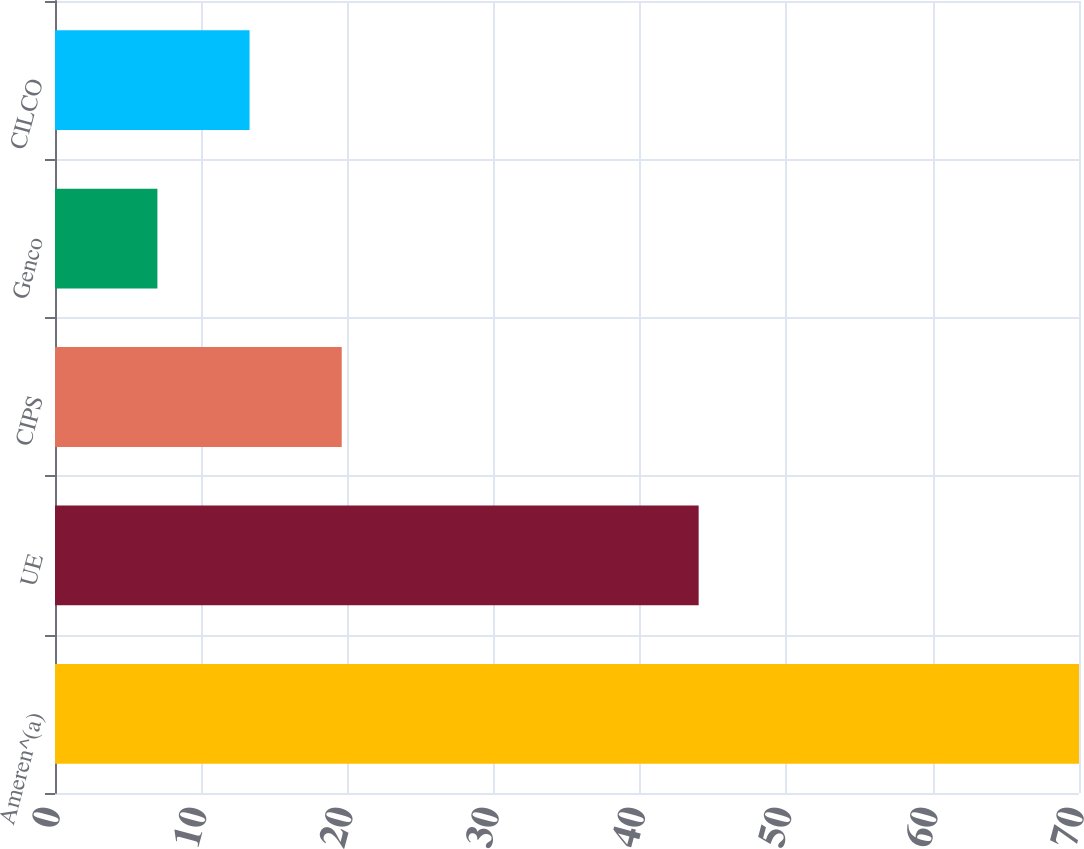Convert chart to OTSL. <chart><loc_0><loc_0><loc_500><loc_500><bar_chart><fcel>Ameren^(a)<fcel>UE<fcel>CIPS<fcel>Genco<fcel>CILCO<nl><fcel>70<fcel>44<fcel>19.6<fcel>7<fcel>13.3<nl></chart> 